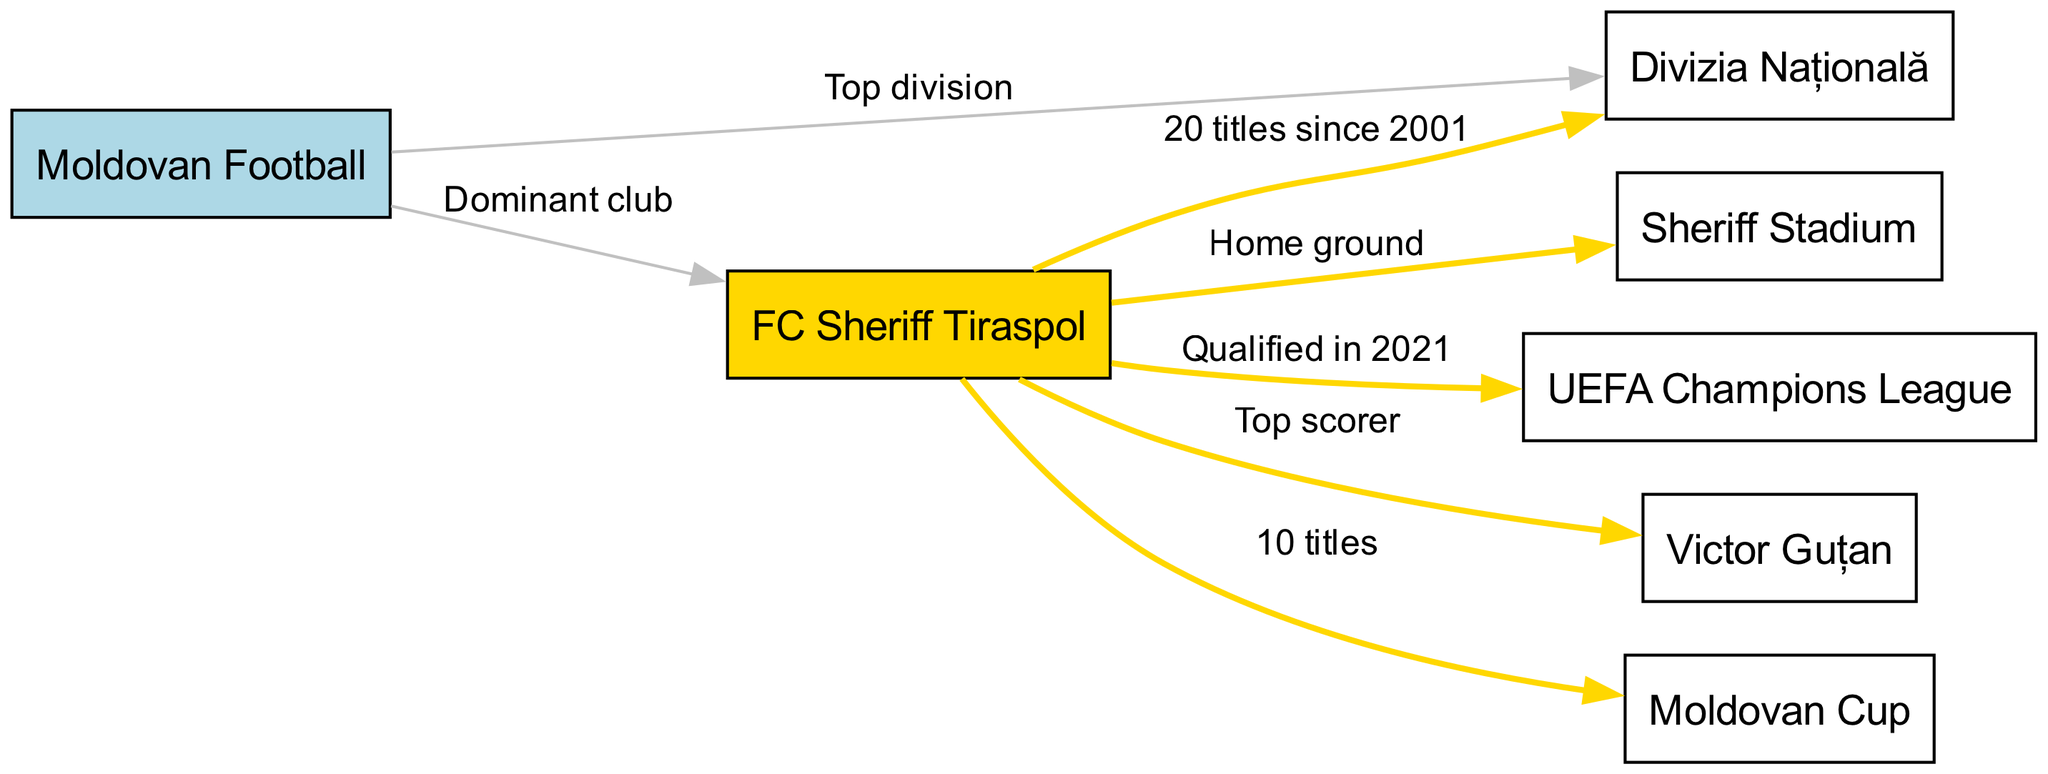What is the dominant club in Moldovan football? The diagram indicates that FC Sheriff Tiraspol is labeled as the "Dominant club" in connection with Moldovan football, which is directly stated in the edge connecting the two nodes.
Answer: FC Sheriff Tiraspol How many titles has FC Sheriff Tiraspol won since 2001? The edge between FC Sheriff Tiraspol and Divizia Națională specifies that the club has won "20 titles since 2001." This fact directly answers the question based on the diagram.
Answer: 20 titles What is the home ground of FC Sheriff Tiraspol? The diagram shows an edge connecting FC Sheriff Tiraspol to Sheriff Stadium and labels this edge as "Home ground," indicating that Sheriff Stadium is where FC Sheriff Tiraspol plays.
Answer: Sheriff Stadium How many Moldovan Cup titles has FC Sheriff Tiraspol achieved? According to the diagram, FC Sheriff Tiraspol has won "10 titles" related to the Moldovan Cup, which is stated clearly on the edge connecting them.
Answer: 10 titles Which major European competition did FC Sheriff Tiraspol qualify for in 2021? The edge connecting FC Sheriff Tiraspol to UEFA Champions League explicitly states that the team "Qualified in 2021," providing the answer directly from the diagram.
Answer: UEFA Champions League Who is the top scorer for FC Sheriff Tiraspol? The diagram identifies Victor Guțan as the link labeled "Top scorer" from FC Sheriff Tiraspol, indicating his significance to the club's scoring achievements.
Answer: Victor Guțan What is the relationship between Moldovan Football and Divizia Națională? The relationship is described by the edge that links Moldovan Football to Divizia Națională, which is labeled "Top division," indicating that Divizia Națională is the premier football division in Moldova.
Answer: Top division How many nodes are there in this concept map? By counting all the distinct elements or "nodes" listed in the diagram data, there are a total of 7 nodes represented in the map detailing various aspects of Moldovan football.
Answer: 7 nodes What color represents FC Sheriff Tiraspol in the diagram? The diagram specifically designates FC Sheriff Tiraspol with a gold fill color, as indicated in the code that highlights this node uniquely compared to others.
Answer: Gold 